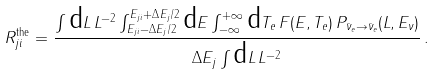Convert formula to latex. <formula><loc_0><loc_0><loc_500><loc_500>R _ { j i } ^ { \text {the} } = \frac { \int \text {d} L \, L ^ { - 2 } \int _ { E _ { j i } - \Delta { E _ { j } } / 2 } ^ { E _ { j i } + \Delta { E _ { j } } / 2 } \text {d} E \int _ { - \infty } ^ { + \infty } \text {d} T _ { e } \, F ( E , T _ { e } ) \, P _ { \bar { \nu } _ { e } \to \bar { \nu } _ { e } } ( L , E _ { \nu } ) } { \Delta { E _ { j } } \int \text {d} L \, L ^ { - 2 } } \, .</formula> 